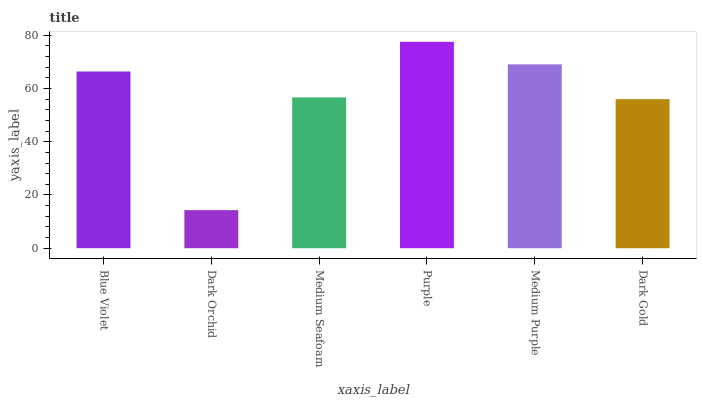Is Dark Orchid the minimum?
Answer yes or no. Yes. Is Purple the maximum?
Answer yes or no. Yes. Is Medium Seafoam the minimum?
Answer yes or no. No. Is Medium Seafoam the maximum?
Answer yes or no. No. Is Medium Seafoam greater than Dark Orchid?
Answer yes or no. Yes. Is Dark Orchid less than Medium Seafoam?
Answer yes or no. Yes. Is Dark Orchid greater than Medium Seafoam?
Answer yes or no. No. Is Medium Seafoam less than Dark Orchid?
Answer yes or no. No. Is Blue Violet the high median?
Answer yes or no. Yes. Is Medium Seafoam the low median?
Answer yes or no. Yes. Is Purple the high median?
Answer yes or no. No. Is Medium Purple the low median?
Answer yes or no. No. 